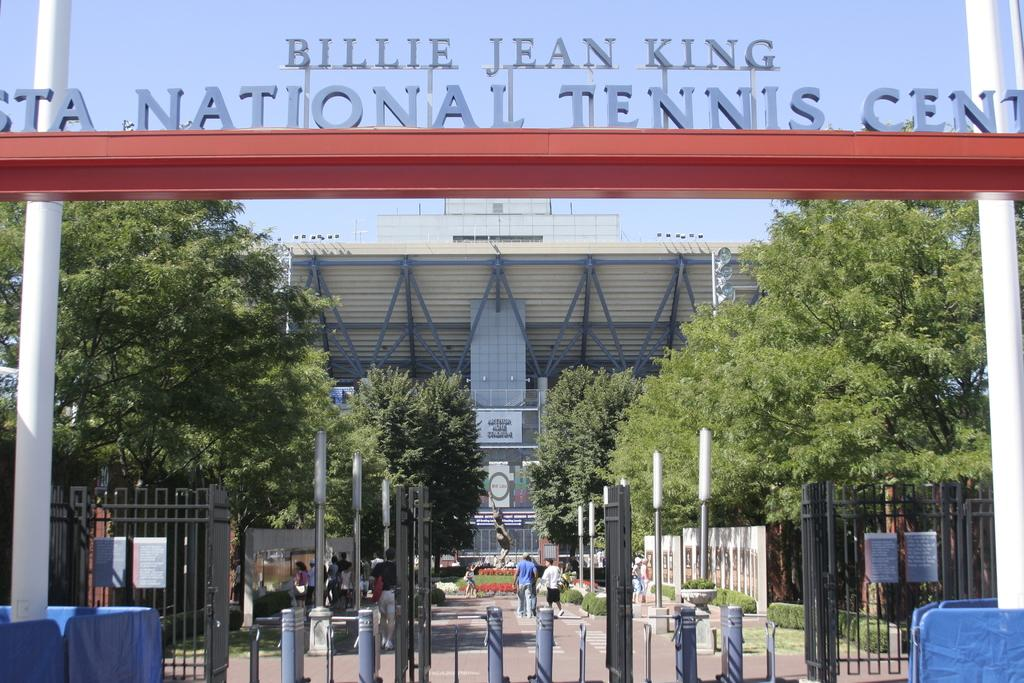What is written or displayed on the entrance in the image? There is text on the entrance in the image. What objects can be seen in the foreground area of the image? There are poles in the foreground area of the image. Can you describe the people visible in the image? There are people visible in the image. What type of natural elements are present in the image? There are trees in the image. What might be the purpose of the boundary or gate in the image? It appears to be a boundary or gate in the image, which could be used to control access or mark a boundary. What is visible in the background of the image? There is a building and the sky visible in the background of the image. What type of pot is being used to water the bushes in the image? There are no bushes or pots present in the image. What color is the ink used to write the text on the entrance? The color of the ink used to write the text on the entrance cannot be determined from the image. 